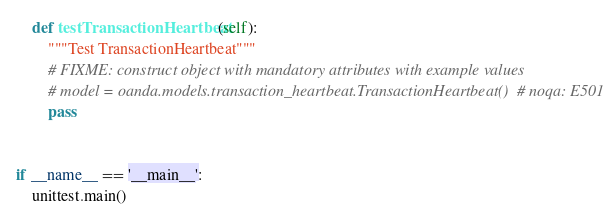Convert code to text. <code><loc_0><loc_0><loc_500><loc_500><_Python_>    def testTransactionHeartbeat(self):
        """Test TransactionHeartbeat"""
        # FIXME: construct object with mandatory attributes with example values
        # model = oanda.models.transaction_heartbeat.TransactionHeartbeat()  # noqa: E501
        pass


if __name__ == '__main__':
    unittest.main()
</code> 